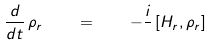<formula> <loc_0><loc_0><loc_500><loc_500>\frac { d } { d t } \, \rho _ { r } \quad = \quad - \frac { i } { } \, [ H _ { r } , \rho _ { r } ]</formula> 